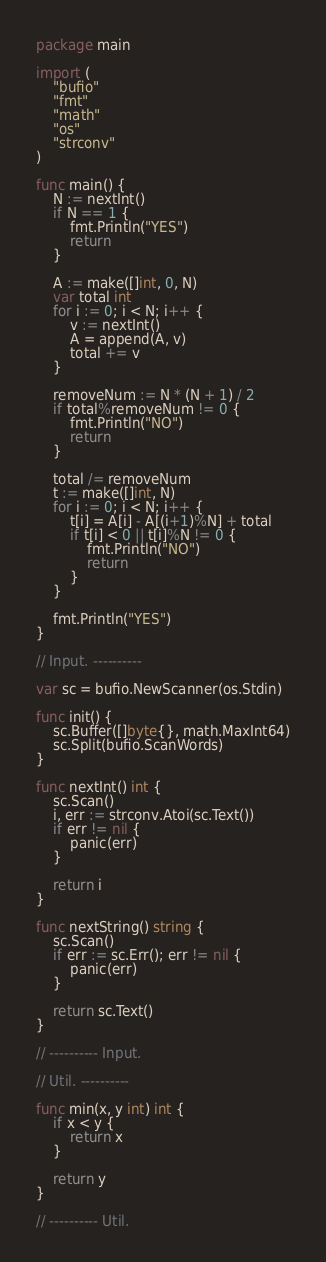<code> <loc_0><loc_0><loc_500><loc_500><_Go_>package main

import (
	"bufio"
	"fmt"
	"math"
	"os"
	"strconv"
)

func main() {
	N := nextInt()
	if N == 1 {
		fmt.Println("YES")
		return
	}

	A := make([]int, 0, N)
	var total int
	for i := 0; i < N; i++ {
		v := nextInt()
		A = append(A, v)
		total += v
	}

	removeNum := N * (N + 1) / 2
	if total%removeNum != 0 {
		fmt.Println("NO")
		return
	}

	total /= removeNum
	t := make([]int, N)
	for i := 0; i < N; i++ {
		t[i] = A[i] - A[(i+1)%N] + total
		if t[i] < 0 || t[i]%N != 0 {
			fmt.Println("NO")
			return
		}
	}

	fmt.Println("YES")
}

// Input. ----------

var sc = bufio.NewScanner(os.Stdin)

func init() {
	sc.Buffer([]byte{}, math.MaxInt64)
	sc.Split(bufio.ScanWords)
}

func nextInt() int {
	sc.Scan()
	i, err := strconv.Atoi(sc.Text())
	if err != nil {
		panic(err)
	}

	return i
}

func nextString() string {
	sc.Scan()
	if err := sc.Err(); err != nil {
		panic(err)
	}

	return sc.Text()
}

// ---------- Input.

// Util. ----------

func min(x, y int) int {
	if x < y {
		return x
	}

	return y
}

// ---------- Util.
</code> 